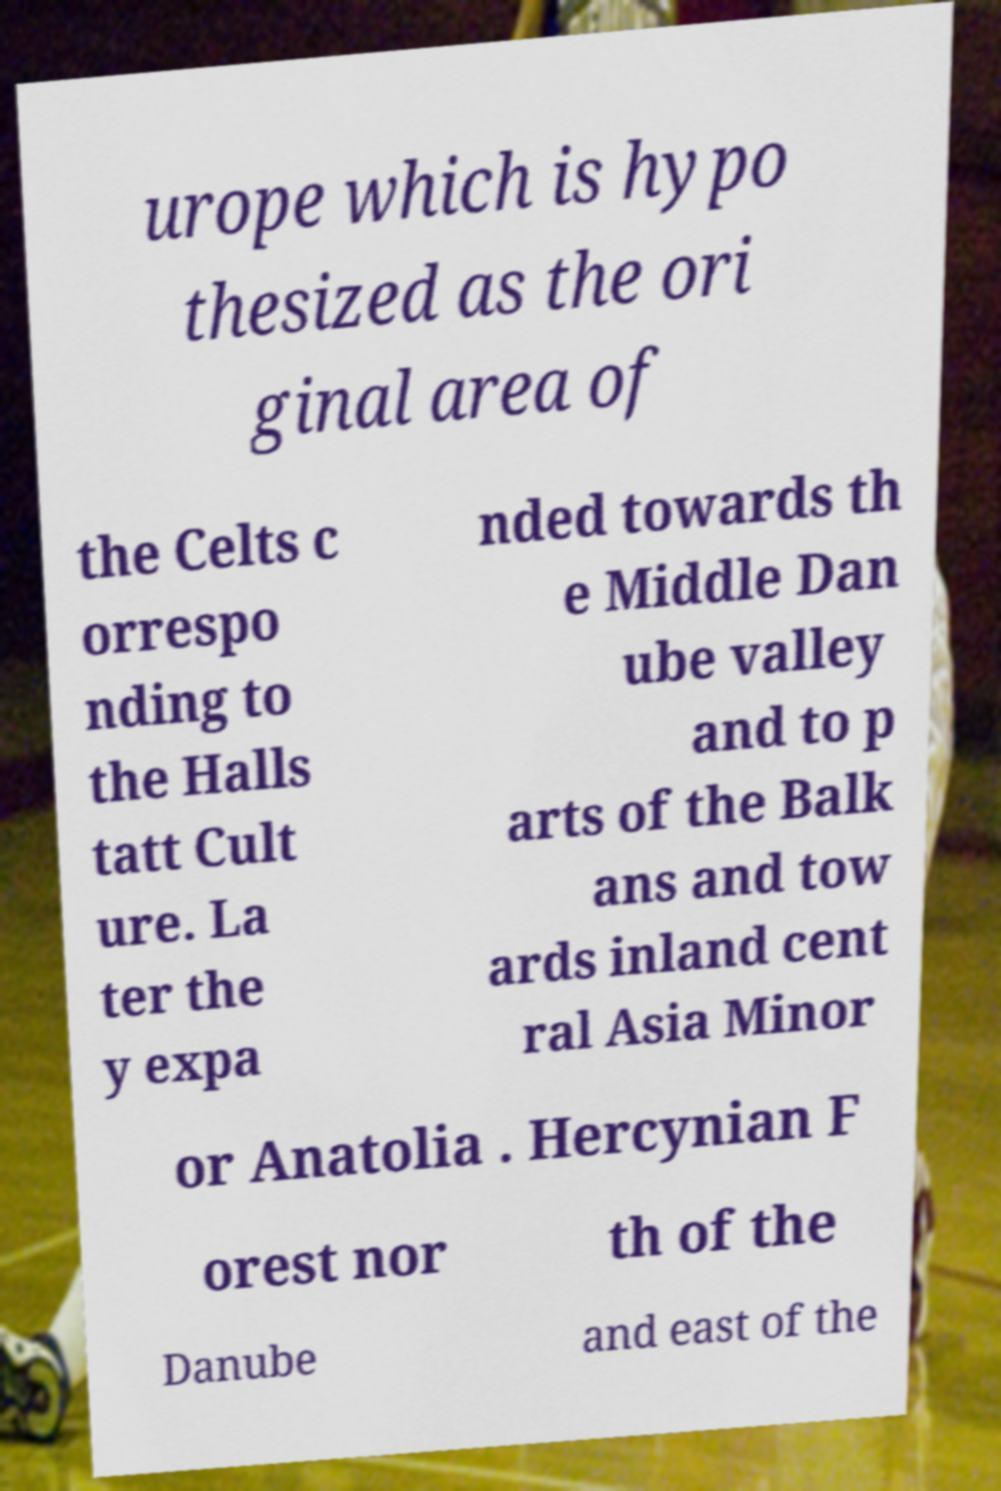Could you extract and type out the text from this image? urope which is hypo thesized as the ori ginal area of the Celts c orrespo nding to the Halls tatt Cult ure. La ter the y expa nded towards th e Middle Dan ube valley and to p arts of the Balk ans and tow ards inland cent ral Asia Minor or Anatolia . Hercynian F orest nor th of the Danube and east of the 